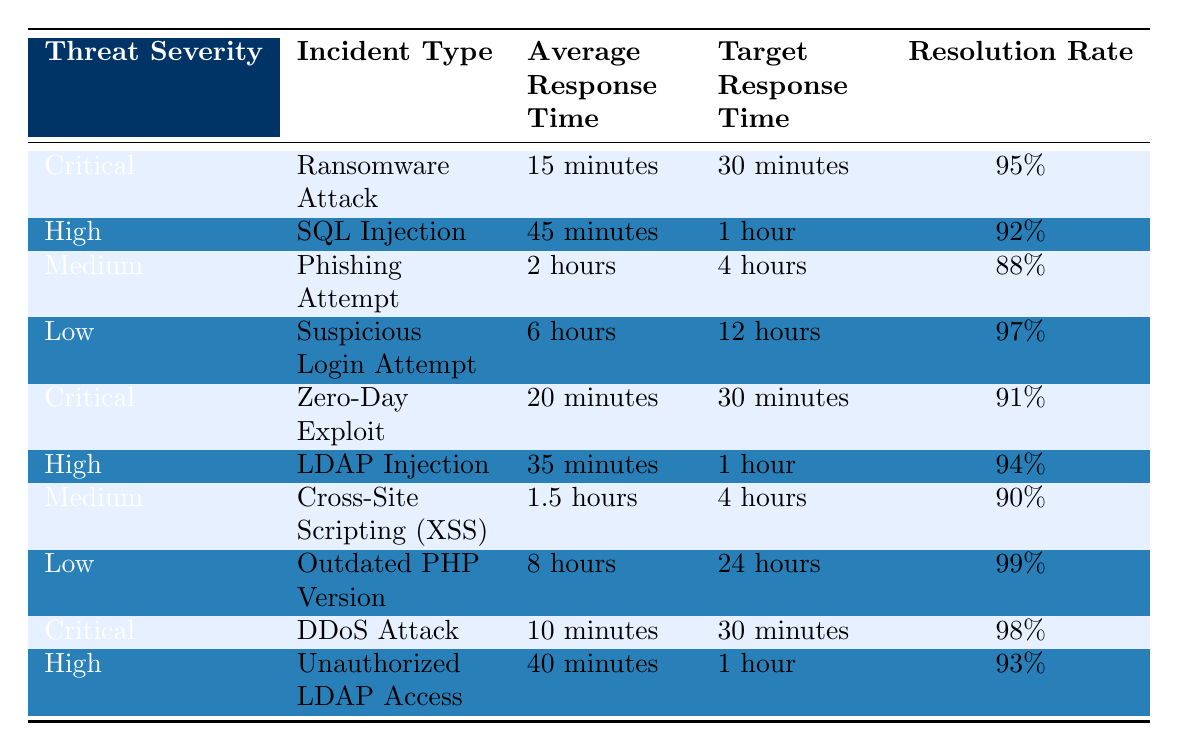What is the average response time for a critical threat severity incident? There are two critical incidents listed: Ransomware Attack (15 minutes) and DDoS Attack (10 minutes). To find the average, add these times together: 15 + 10 = 25 minutes, then divide by 2: 25/2 = 12.5 minutes.
Answer: 12.5 minutes How long is the target response time for low severity incidents? There are two low severity incidents: Suspicious Login Attempt (12 hours) and Outdated PHP Version (24 hours). The target response time for low severity incidents is 12 hours since it is the only time mentioned.
Answer: 12 hours What is the resolution rate for the SQL Injection incident? Referring to the row for SQL Injection, the resolution rate is specifically mentioned as 92%.
Answer: 92% Are all critical incidents resolved in under 30 minutes on average? The average response times for critical incidents are Ransomware Attack (15 minutes) and DDoS Attack (10 minutes), both of which are under the target response time of 30 minutes. Yes, both incidents have resolution times under 30 minutes.
Answer: Yes Which incident has the longest average response time? From the data, Outdated PHP Version has the longest average response time of 8 hours, compared to all other incidents listed.
Answer: Outdated PHP Version How many incidents have a resolution rate above 90%? The incidents with resolution rates above 90% are Ransomware Attack (95%), Zero-Day Exploit (91%), DDoS Attack (98%), LDAP Injection (94%), and Unauthorized LDAP Access (93%). This totals five incidents.
Answer: 5 What is the difference between the average response times of high severity incidents and low severity incidents? High severity incidents: SQL Injection (45 minutes) and LDAP Injection (35 minutes) average to (45 + 35) / 2 = 40 minutes. Low severity incidents: Suspicious Login Attempt (6 hours = 360 minutes) and Outdated PHP Version (8 hours = 480 minutes) average to (360 + 480) / 2 = 420 minutes or 7 hours. The difference in average response times is 420 - 40 = 380 minutes.
Answer: 380 minutes Is there any incident type that has an average response time exceeding 2 hours? The incidents with response times are Phishing Attempt (2 hours), Suspicious Login Attempt (6 hours), and Outdated PHP Version (8 hours). Therefore, there are incidents exceeding 2 hours.
Answer: Yes Which incident type has the lowest resolution rate? The incident with the lowest resolution rate is at the Phishing Attempt, having a rate of 88%, which is lower than any other listed incident.
Answer: Phishing Attempt What percentage of critical incidents have an average response time greater than 15 minutes? There are three critical incidents: Ransomware Attack (15 minutes, not greater), Zero-Day Exploit (20 minutes, greater), and DDoS Attack (10 minutes, not greater). Only 1 out of 3 incidents exceeds 15 minutes, so (1/3) * 100 = 33.33%.
Answer: 33.33% 